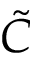<formula> <loc_0><loc_0><loc_500><loc_500>\tilde { C }</formula> 